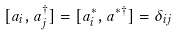<formula> <loc_0><loc_0><loc_500><loc_500>[ a _ { i } , a ^ { \dagger } _ { j } ] = [ a ^ { * } _ { i } , a ^ { * { \dagger } } ] = \delta _ { i j }</formula> 